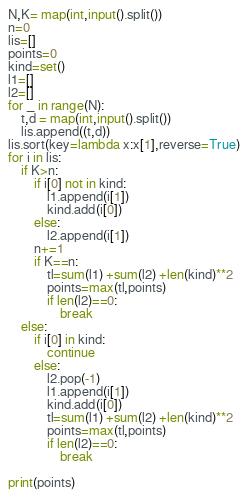Convert code to text. <code><loc_0><loc_0><loc_500><loc_500><_Python_>N,K= map(int,input().split())
n=0
lis=[]
points=0
kind=set()
l1=[]
l2=[]
for _ in range(N):
    t,d = map(int,input().split())
    lis.append((t,d))
lis.sort(key=lambda x:x[1],reverse=True)
for i in lis:
    if K>n:
        if i[0] not in kind:
            l1.append(i[1])
            kind.add(i[0])
        else:
            l2.append(i[1])
        n+=1
        if K==n:
            tl=sum(l1) +sum(l2) +len(kind)**2
            points=max(tl,points)
            if len(l2)==0:
                break
    else:
        if i[0] in kind:
            continue
        else:
            l2.pop(-1)
            l1.append(i[1])
            kind.add(i[0])
            tl=sum(l1) +sum(l2) +len(kind)**2
            points=max(tl,points)
            if len(l2)==0:
                break

print(points)</code> 